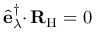Convert formula to latex. <formula><loc_0><loc_0><loc_500><loc_500>\hat { e } _ { \lambda } ^ { \dagger } { \cdot } \, { R } _ { H } = 0</formula> 